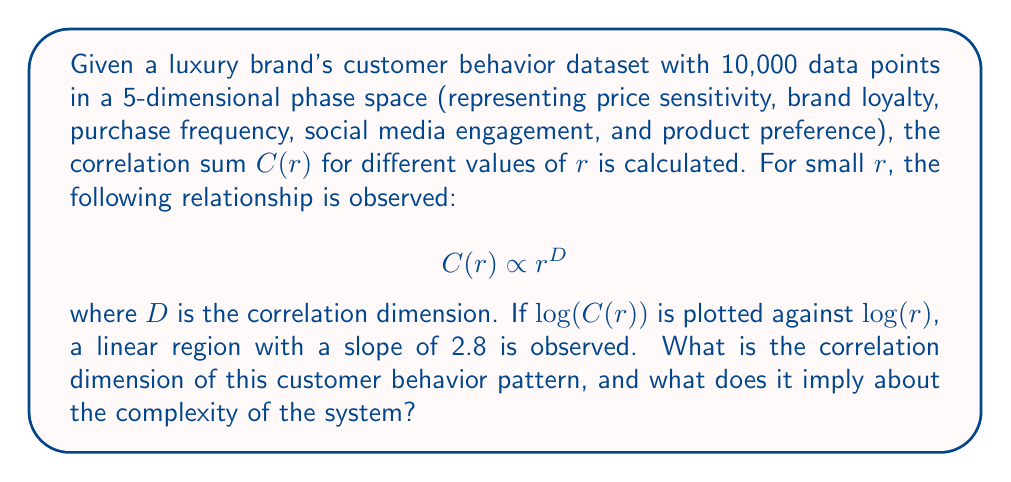Show me your answer to this math problem. To determine the correlation dimension and its implications, let's follow these steps:

1. Recall the relationship between $C(r)$ and $r$:
   $$C(r) \propto r^D$$

2. Taking the logarithm of both sides:
   $$\log(C(r)) \propto D \log(r)$$

3. This logarithmic relationship explains why we plot $\log(C(r))$ against $\log(r)$. The slope of the linear region in this plot represents the correlation dimension $D$.

4. Given information: The slope of the linear region is 2.8.

5. Therefore, the correlation dimension $D = 2.8$.

6. Interpretation:
   - The correlation dimension is a non-integer (fractal) value, indicating complex, chaotic behavior in the customer patterns.
   - $D = 2.8$ suggests that the system's behavior can be described by fewer than 3 variables, despite being in a 5-dimensional phase space.
   - This implies that customer behavior, while complex, has some underlying structure and is not purely random.
   - For the luxury brand, this means that customer behavior patterns are sophisticated but potentially predictable with the right analytical tools.

7. Implications for the luxury brand:
   - The brand can focus on 2-3 key factors that most influence customer behavior, simplifying their rebranding strategy.
   - The fractal nature suggests that similar patterns may exist at different scales (e.g., among different customer segments or time scales), which can inform targeted marketing strategies.
   - The complexity indicates that small changes in strategy could lead to significant shifts in customer behavior, emphasizing the importance of careful, data-driven decision-making in maintaining elegance and sophistication.
Answer: $D = 2.8$; implies complex but potentially predictable customer behavior patterns. 